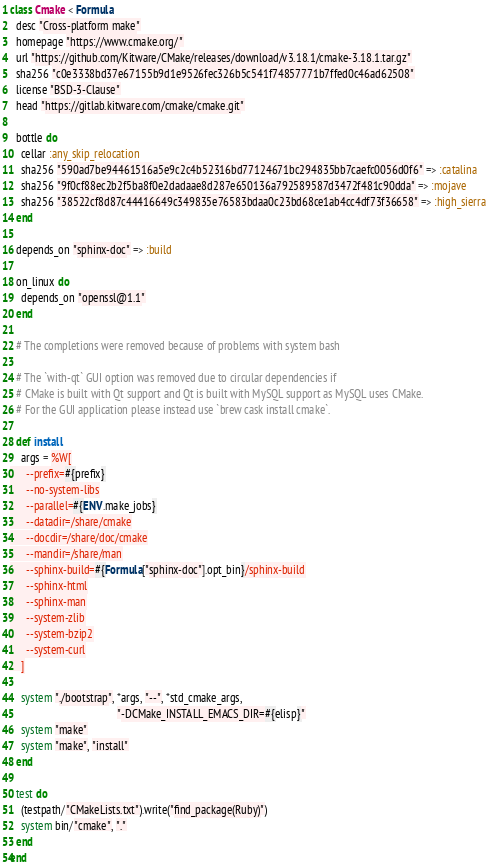<code> <loc_0><loc_0><loc_500><loc_500><_Ruby_>class Cmake < Formula
  desc "Cross-platform make"
  homepage "https://www.cmake.org/"
  url "https://github.com/Kitware/CMake/releases/download/v3.18.1/cmake-3.18.1.tar.gz"
  sha256 "c0e3338bd37e67155b9d1e9526fec326b5c541f74857771b7ffed0c46ad62508"
  license "BSD-3-Clause"
  head "https://gitlab.kitware.com/cmake/cmake.git"

  bottle do
    cellar :any_skip_relocation
    sha256 "590ad7be94461516a5e9c2c4b52316bd77124671bc294835bb7caefc0056d0f6" => :catalina
    sha256 "9f0cf88ec2b2f5ba8f0e2dadaae8d287e650136a792589587d3472f481c90dda" => :mojave
    sha256 "38522cf8d87c44416649c349835e76583bdaa0c23bd68ce1ab4cc4df73f36658" => :high_sierra
  end

  depends_on "sphinx-doc" => :build

  on_linux do
    depends_on "openssl@1.1"
  end

  # The completions were removed because of problems with system bash

  # The `with-qt` GUI option was removed due to circular dependencies if
  # CMake is built with Qt support and Qt is built with MySQL support as MySQL uses CMake.
  # For the GUI application please instead use `brew cask install cmake`.

  def install
    args = %W[
      --prefix=#{prefix}
      --no-system-libs
      --parallel=#{ENV.make_jobs}
      --datadir=/share/cmake
      --docdir=/share/doc/cmake
      --mandir=/share/man
      --sphinx-build=#{Formula["sphinx-doc"].opt_bin}/sphinx-build
      --sphinx-html
      --sphinx-man
      --system-zlib
      --system-bzip2
      --system-curl
    ]

    system "./bootstrap", *args, "--", *std_cmake_args,
                                       "-DCMake_INSTALL_EMACS_DIR=#{elisp}"
    system "make"
    system "make", "install"
  end

  test do
    (testpath/"CMakeLists.txt").write("find_package(Ruby)")
    system bin/"cmake", "."
  end
end
</code> 